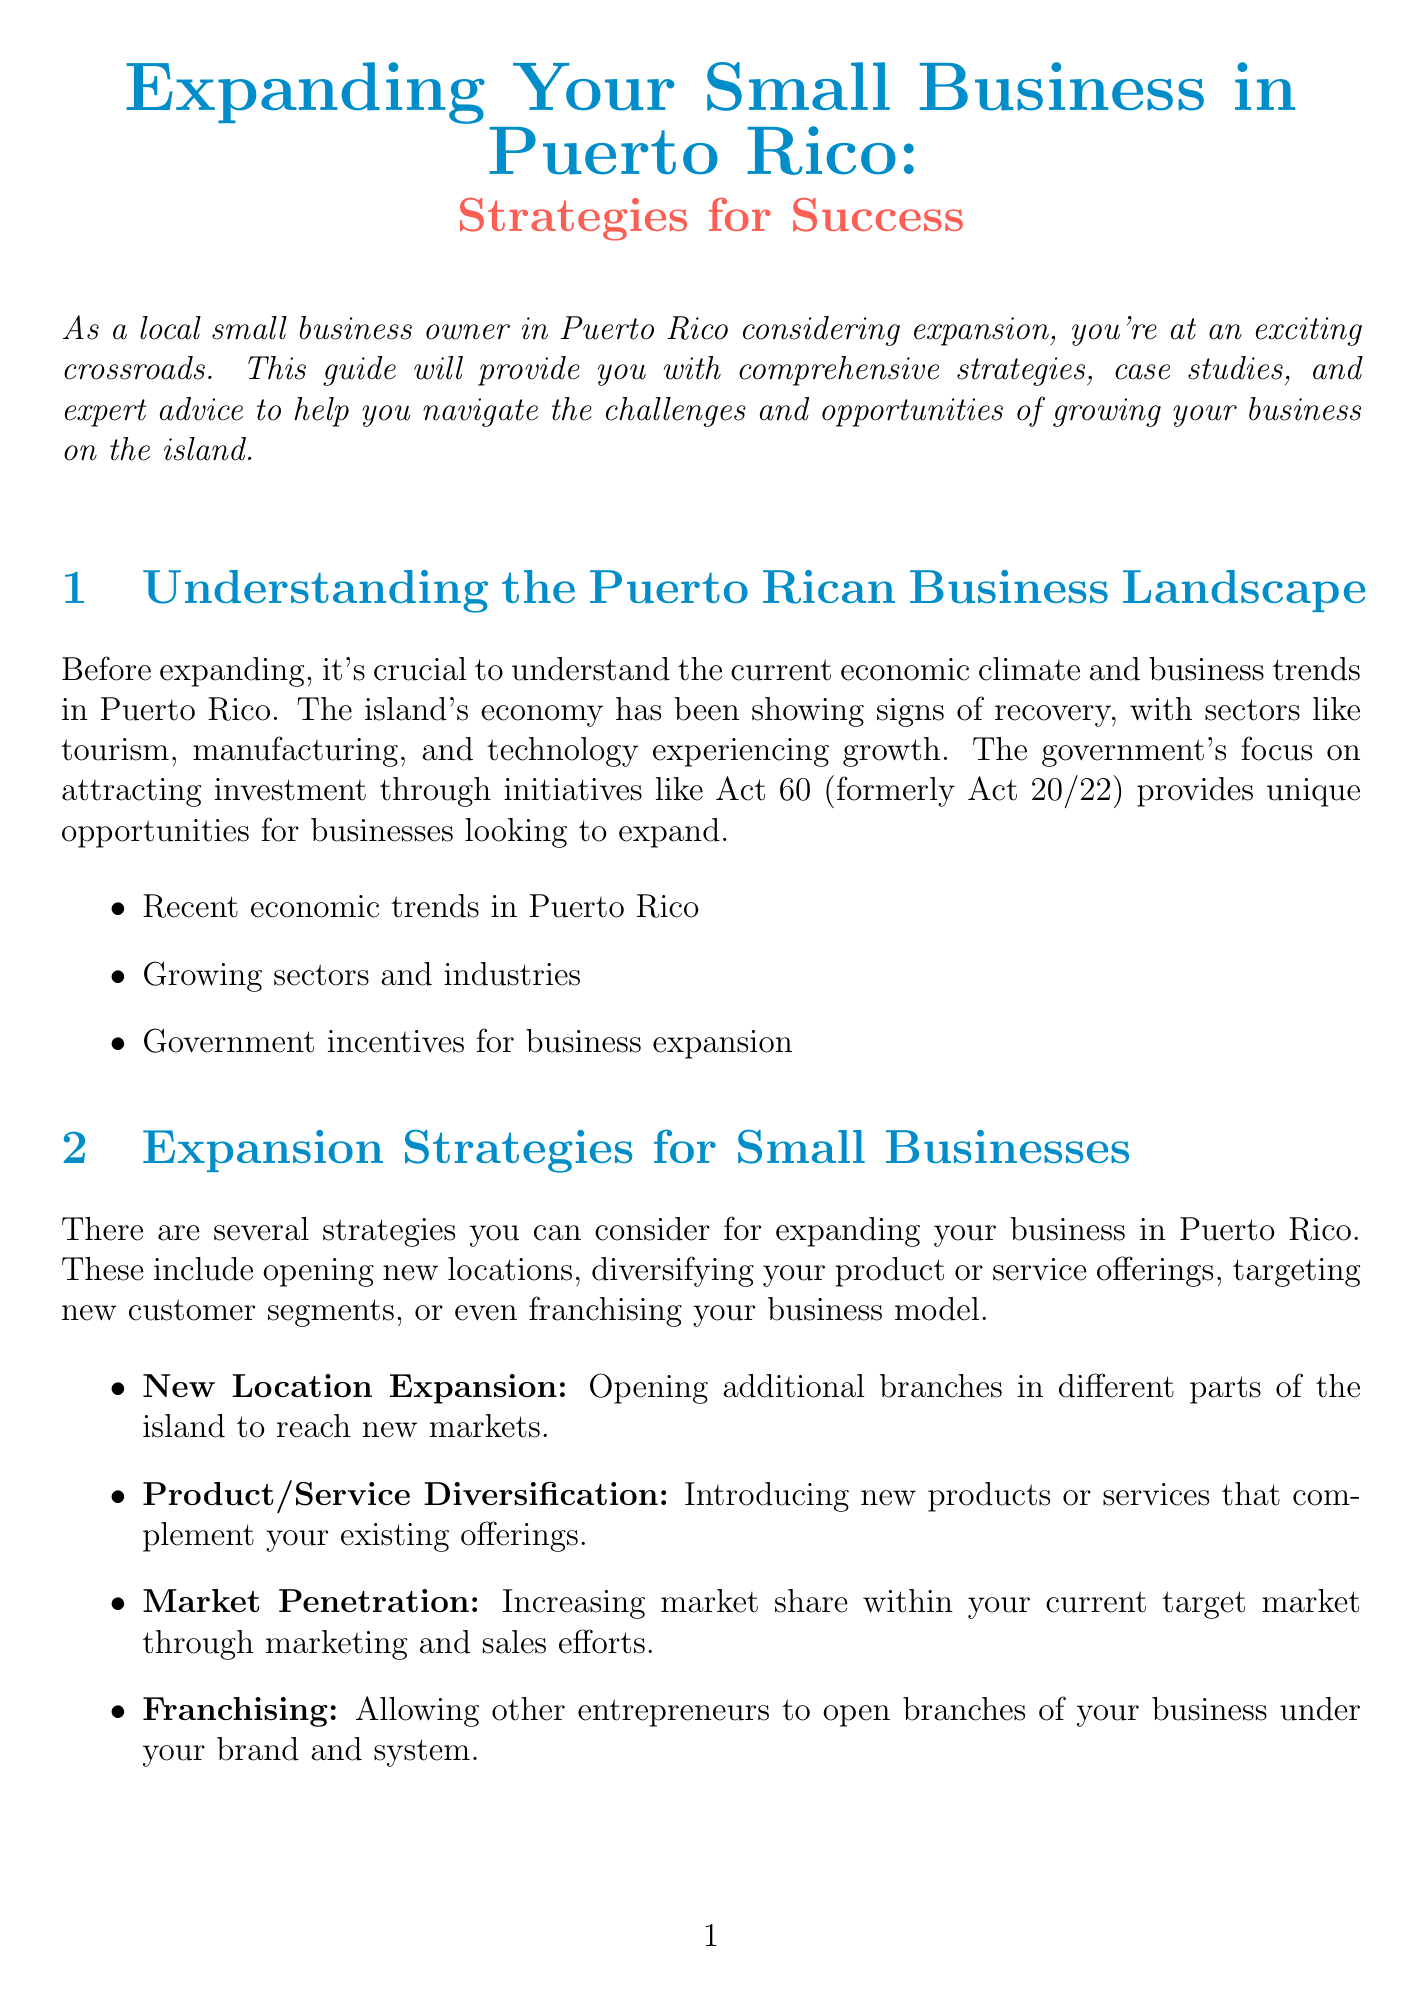What is the title of the newsletter? The title of the newsletter is presented in a prominent position at the top of the document.
Answer: Expanding Your Small Business in Puerto Rico: Strategies for Success Who is the expert providing advice in the newsletter? The expert's name is mentioned in the section about expert advice, where their role is also specified.
Answer: María Rodriguez What year did Señor Paleta start its operation? The document specifies the year when Señor Paleta began its business.
Answer: 2014 Which government initiative is mentioned as an opportunity for business expansion? The document references a specific government initiative aimed at attracting investment.
Answer: Act 60 What type of funding source includes angel investors? The financial considerations section lists various funding options, including those that involve private investors.
Answer: Angel investors or venture capital What is a suggested technology for improving online presence? The document mentions specific technological tools that can aid in business expansion, including e-commerce platforms.
Answer: Shopify What is emphasized as crucial before expanding a business? The expert advice section highlights a preparatory action necessary for business growth.
Answer: Conduct thorough market research Which strategic option involves opening additional branches? The strategies section outlines various methods for business expansion, including this particular approach.
Answer: New Location Expansion What should be considered to ensure compliance when expanding? The legal and regulatory considerations section mentions various requirements that need to be addressed during expansion.
Answer: Business permits and licenses 